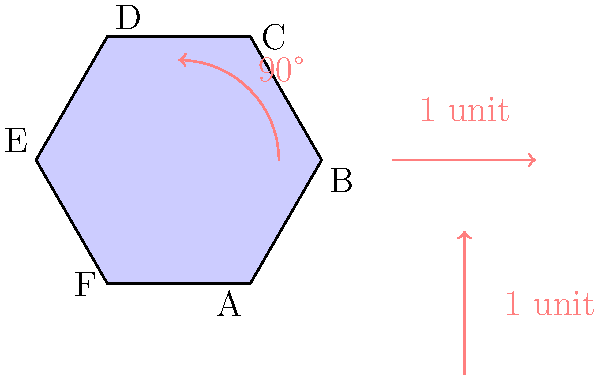A regular hexagon ABCDEF is subjected to the following sequence of transformations:
1. Rotation of 90° clockwise around the origin
2. Translation 1 unit right
3. Translation 1 unit up

Describe the final orientation of the hexagon in relation to its original position. How would you express this as a single transformation? Let's break this down step-by-step:

1. Rotation of 90° clockwise:
   - This moves A to where F was, B to where A was, and so on.
   - The hexagon is now standing on one of its vertices.

2. Translation 1 unit right:
   - This shifts the entire rotated hexagon 1 unit to the right.

3. Translation 1 unit up:
   - This further shifts the hexagon 1 unit upwards.

To express this as a single transformation:

1. The net translation is 1 unit right and 1 unit up, which can be expressed as a translation of $\sqrt{2}$ units at a 45° angle from the positive x-axis.

2. The rotation remains 90° clockwise.

3. In transformational geometry, rotations are typically performed around a fixed point (usually the origin). The given sequence of transformations is equivalent to:
   - A 90° clockwise rotation around a point that is 1 unit right and 1 unit up from the original center of the hexagon.

This is because rotating first and then translating is equivalent to rotating around a translated center point.
Answer: 90° clockwise rotation around the point (1,1) relative to the hexagon's original center. 